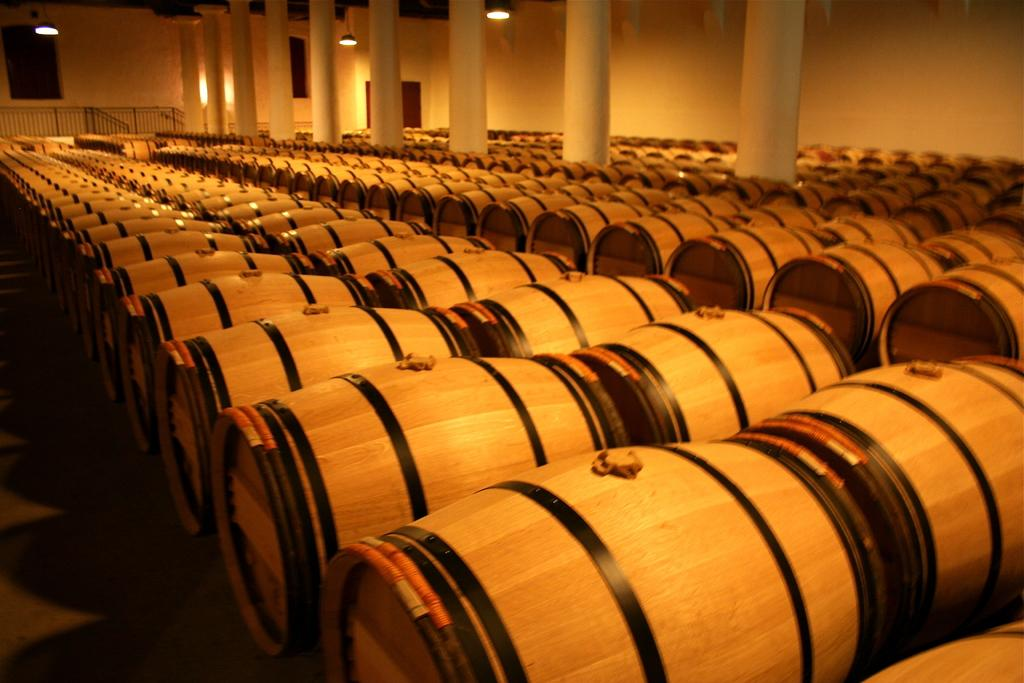What type of objects can be seen in the image? There are many wooden barrels in the image. What architectural features are present in the image? There are pillars in the image. What can be seen in the background of the image? There is a railing and lights on the ceiling in the background of the image. Reasoning: Let' Let's think step by step in order to produce the conversation. We start by identifying the main objects in the image, which are the wooden barrels. Then, we describe the architectural features present, which are the pillars. Finally, we mention the elements visible in the background, which are the railing and lights on the ceiling. Each question is designed to elicit a specific detail about the image that is known from the provided facts. Absurd Question/Answer: What type of pen is being used to write on the barrels in the image? There is no pen or writing visible on the barrels in the image. What type of pleasure can be seen being derived from the barrels in the image? There is no indication of pleasure being derived from the barrels in the image; they are simply objects in the scene. 